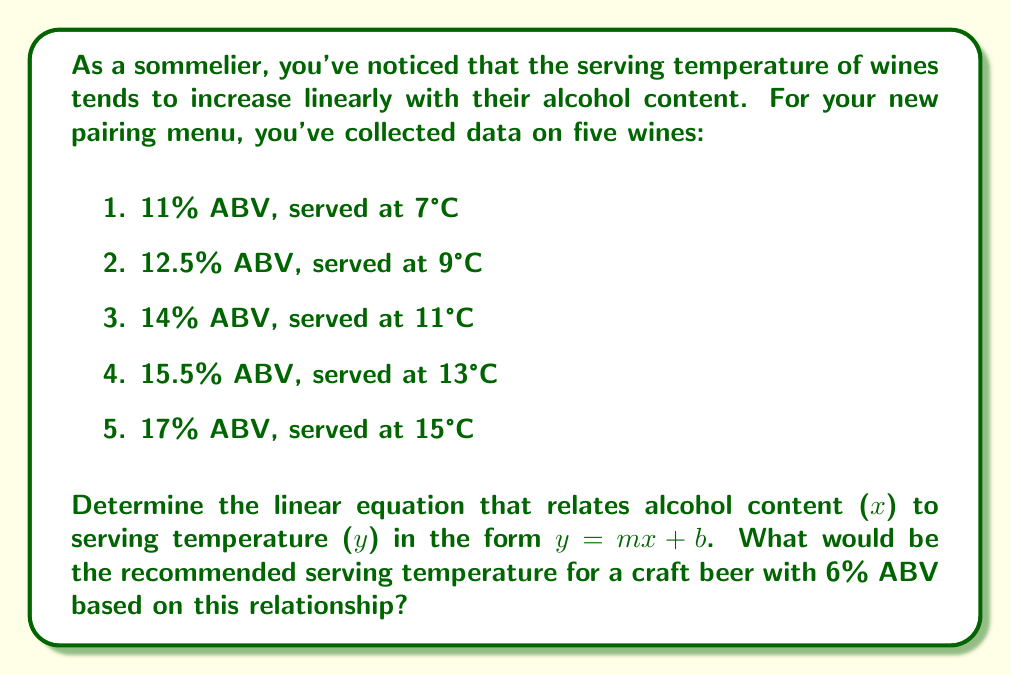Show me your answer to this math problem. To find the linear equation, we'll use the point-slope form and then convert it to slope-intercept form.

Step 1: Calculate the slope (m) using two points.
$m = \frac{y_2 - y_1}{x_2 - x_1} = \frac{15 - 7}{17 - 11} = \frac{8}{6} = \frac{4}{3} \approx 1.33$

Step 2: Use the point-slope form with one of the points, e.g., (11, 7).
$y - 7 = \frac{4}{3}(x - 11)$

Step 3: Expand the equation.
$y - 7 = \frac{4}{3}x - \frac{44}{3}$

Step 4: Solve for y to get the slope-intercept form.
$y = \frac{4}{3}x - \frac{44}{3} + 7$
$y = \frac{4}{3}x - \frac{23}{3}$

Step 5: Simplify the fraction.
$y = \frac{4}{3}x - 7.67$

Now we have our linear equation: $y = \frac{4}{3}x - 7.67$

To find the recommended serving temperature for a 6% ABV craft beer:

Step 6: Plug x = 6 into the equation.
$y = \frac{4}{3}(6) - 7.67$
$y = 8 - 7.67$
$y = 0.33$

Therefore, the recommended serving temperature for a 6% ABV craft beer would be approximately 0.33°C.
Answer: $y = \frac{4}{3}x - 7.67$; 0.33°C 